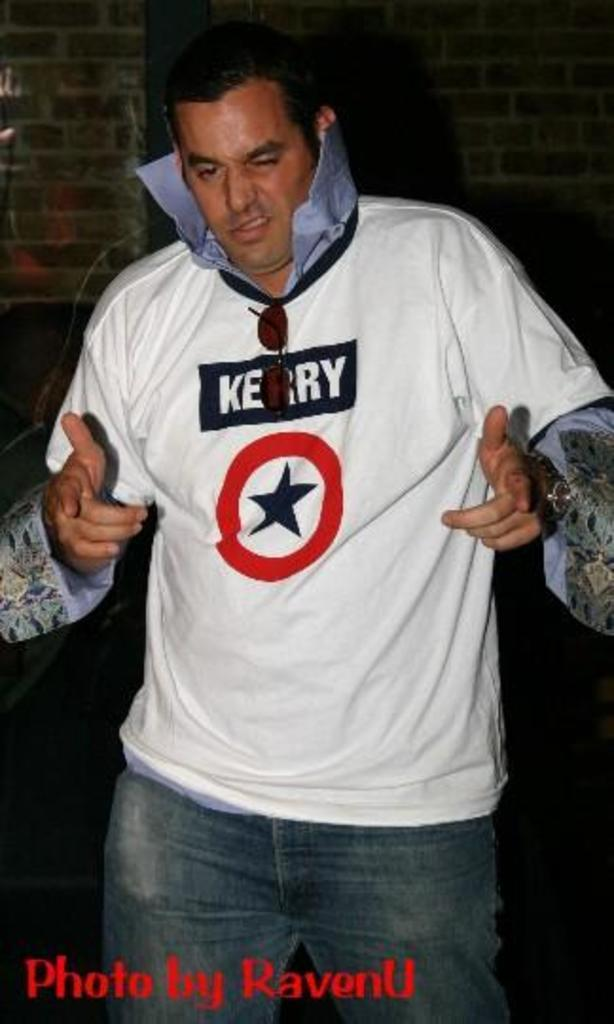<image>
Give a short and clear explanation of the subsequent image. A man with a popped collar and a shirt with "Kerry" on it. 